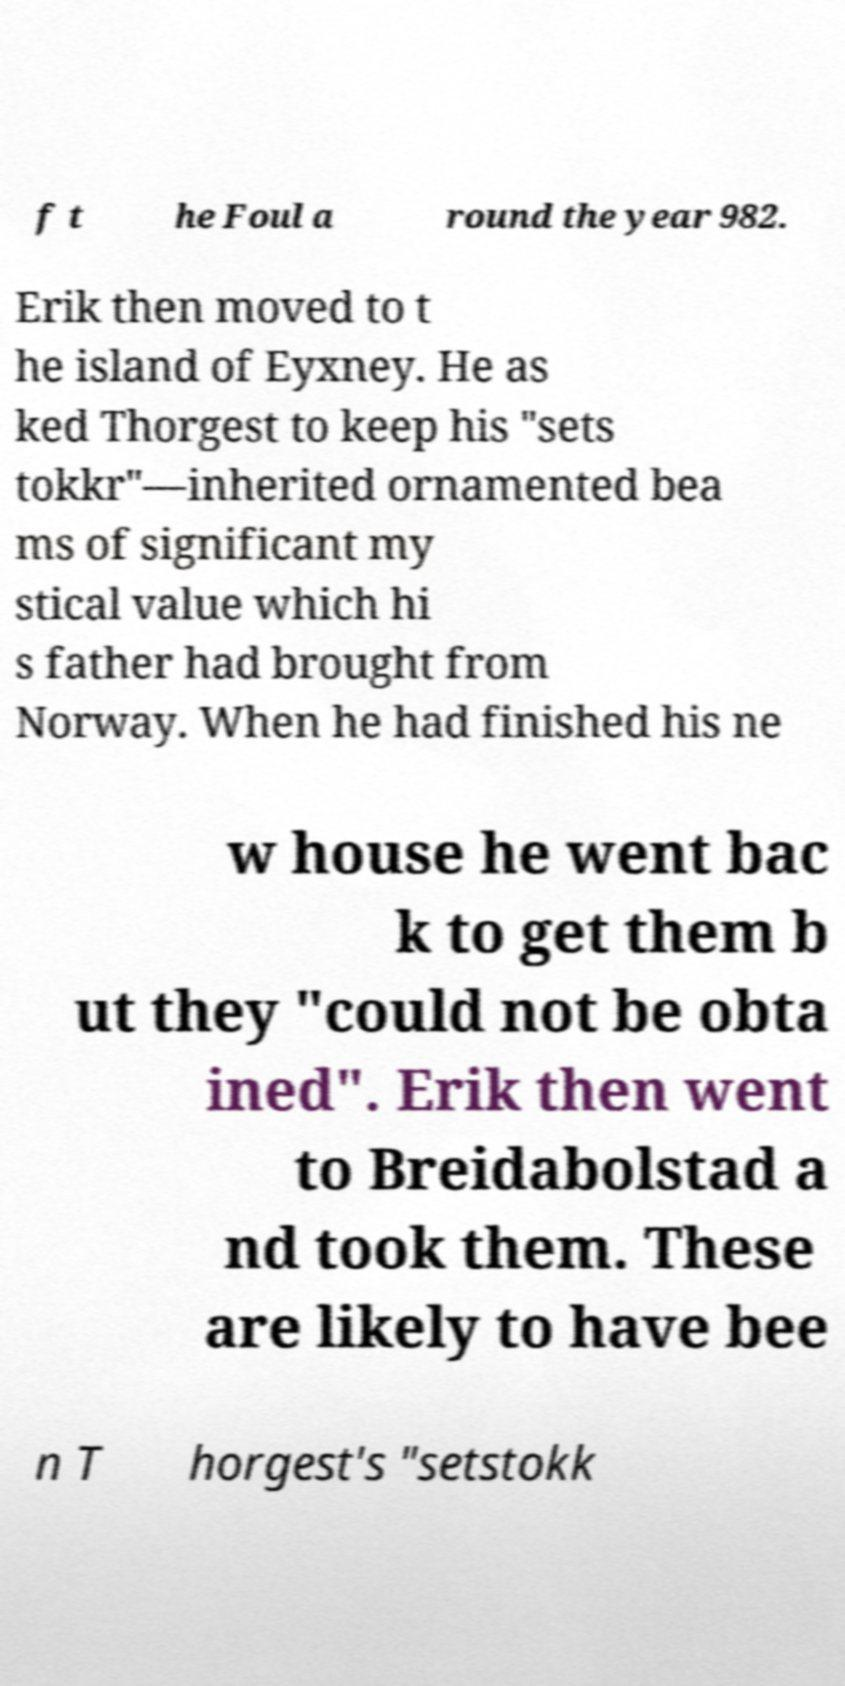For documentation purposes, I need the text within this image transcribed. Could you provide that? f t he Foul a round the year 982. Erik then moved to t he island of Eyxney. He as ked Thorgest to keep his "sets tokkr"—inherited ornamented bea ms of significant my stical value which hi s father had brought from Norway. When he had finished his ne w house he went bac k to get them b ut they "could not be obta ined". Erik then went to Breidabolstad a nd took them. These are likely to have bee n T horgest's "setstokk 